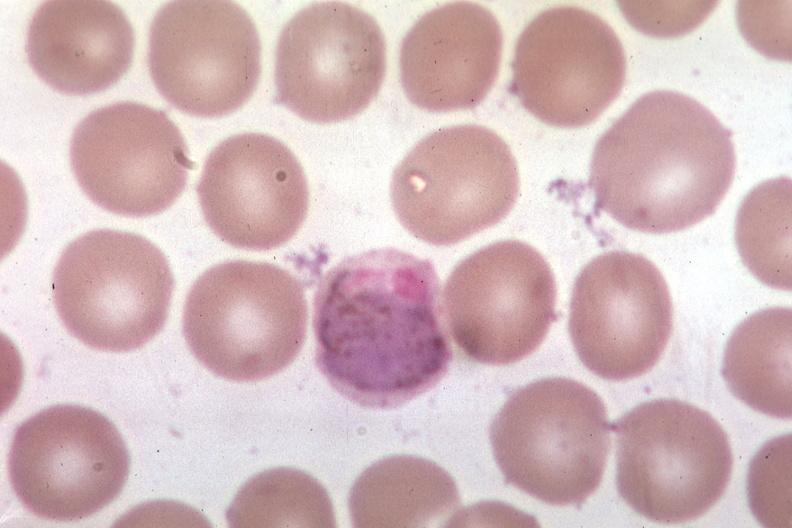s bone, mandible present?
Answer the question using a single word or phrase. No 